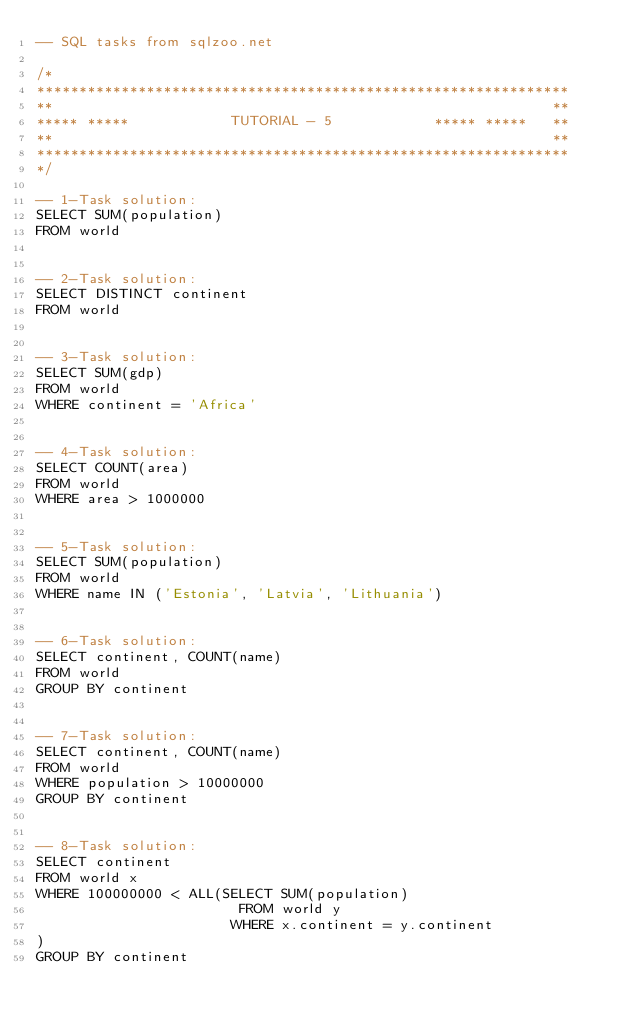Convert code to text. <code><loc_0><loc_0><loc_500><loc_500><_SQL_>-- SQL tasks from sqlzoo.net

/*
***************************************************************
**                                                           **
***** *****            TUTORIAL - 5            ***** *****   **
**                                                           **
***************************************************************
*/

-- 1-Task solution:
SELECT SUM(population)
FROM world


-- 2-Task solution:
SELECT DISTINCT continent
FROM world


-- 3-Task solution:
SELECT SUM(gdp)
FROM world
WHERE continent = 'Africa'


-- 4-Task solution:
SELECT COUNT(area)
FROM world
WHERE area > 1000000


-- 5-Task solution:
SELECT SUM(population)
FROM world
WHERE name IN ('Estonia', 'Latvia', 'Lithuania')


-- 6-Task solution:
SELECT continent, COUNT(name)
FROM world
GROUP BY continent


-- 7-Task solution:
SELECT continent, COUNT(name)
FROM world
WHERE population > 10000000
GROUP BY continent


-- 8-Task solution:
SELECT continent
FROM world x
WHERE 100000000 < ALL(SELECT SUM(population)
                        FROM world y
                       WHERE x.continent = y.continent
)
GROUP BY continent</code> 